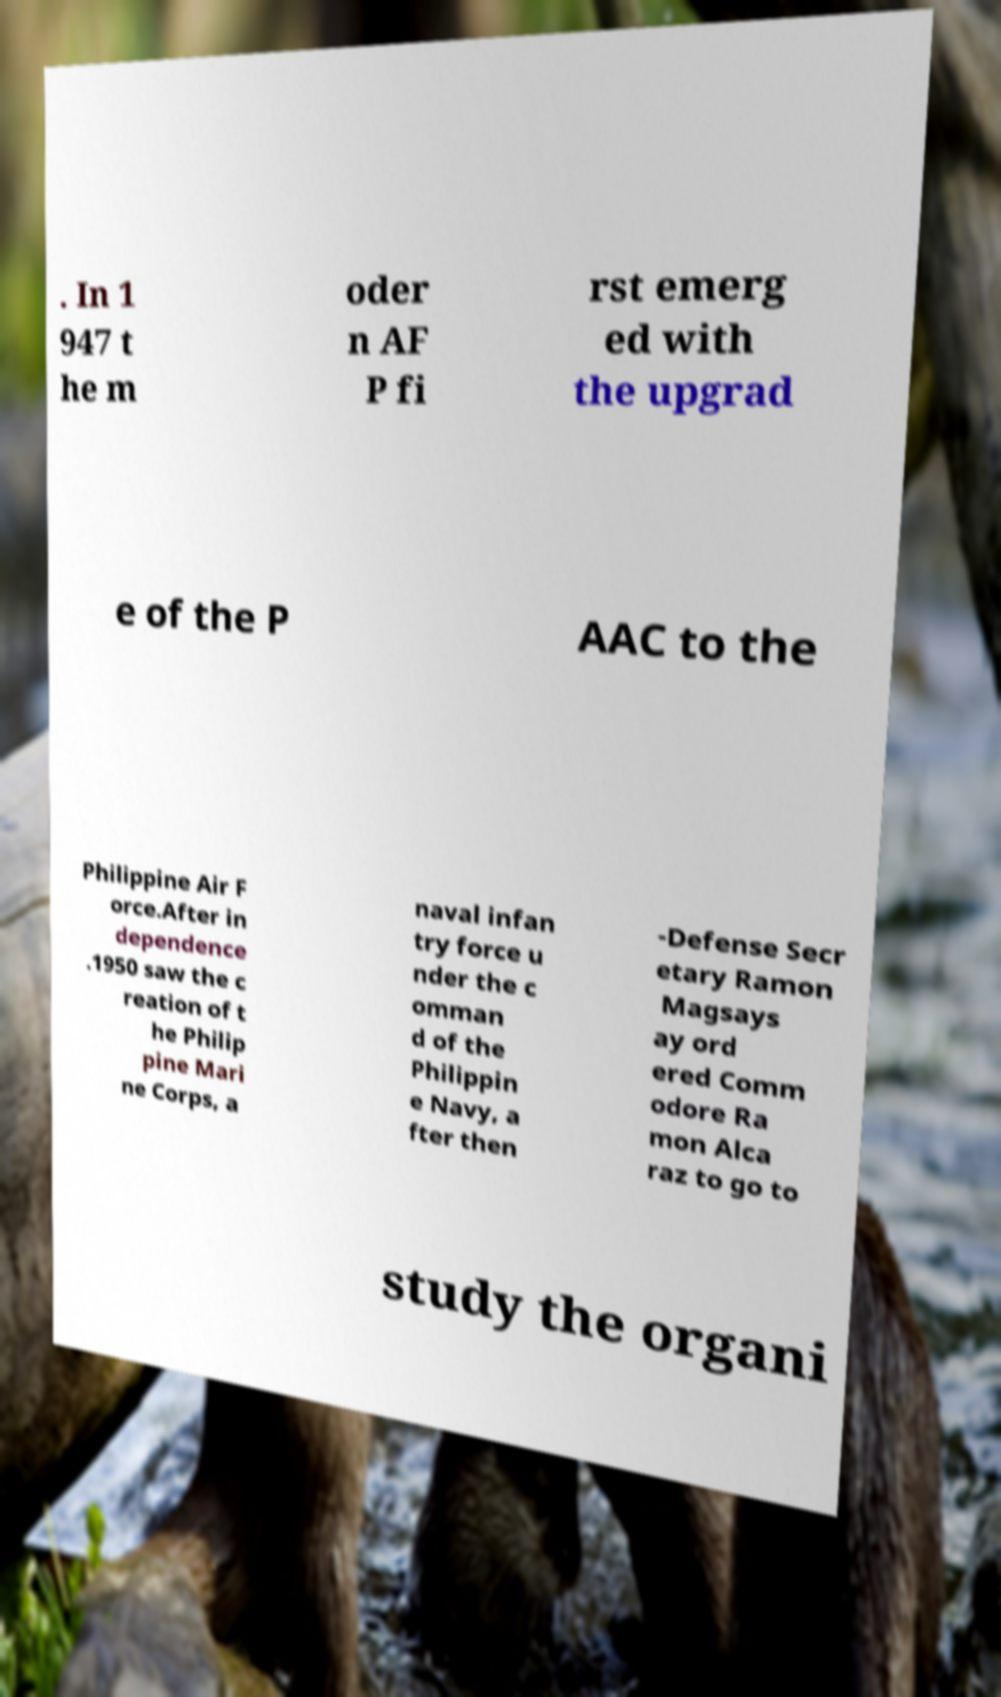Can you read and provide the text displayed in the image?This photo seems to have some interesting text. Can you extract and type it out for me? . In 1 947 t he m oder n AF P fi rst emerg ed with the upgrad e of the P AAC to the Philippine Air F orce.After in dependence .1950 saw the c reation of t he Philip pine Mari ne Corps, a naval infan try force u nder the c omman d of the Philippin e Navy, a fter then -Defense Secr etary Ramon Magsays ay ord ered Comm odore Ra mon Alca raz to go to study the organi 